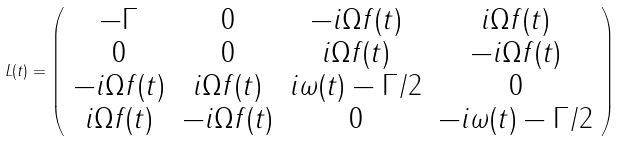<formula> <loc_0><loc_0><loc_500><loc_500>L ( t ) = \left ( \begin{array} { c c c c } - \Gamma & 0 & - i \Omega f ( t ) & i \Omega f ( t ) \\ 0 & 0 & i \Omega f ( t ) & - i \Omega f ( t ) \\ - i \Omega f ( t ) & i \Omega f ( t ) & i \omega ( t ) - \Gamma / 2 & 0 \\ i \Omega f ( t ) & - i \Omega f ( t ) & 0 & - i \omega ( t ) - \Gamma / 2 \end{array} \right )</formula> 